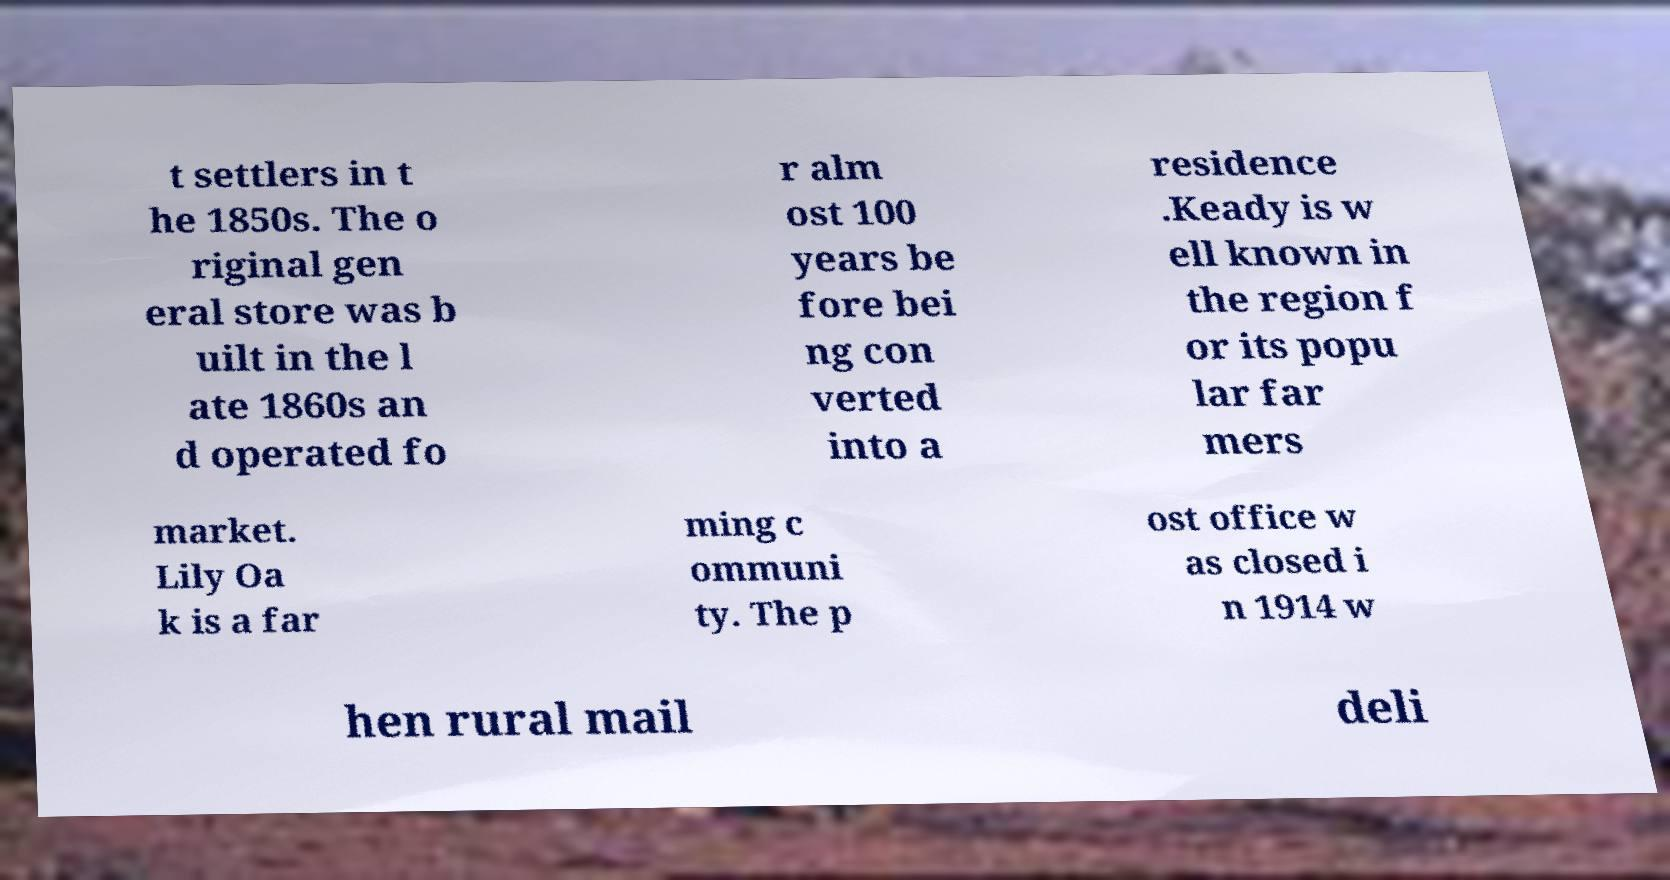Can you accurately transcribe the text from the provided image for me? t settlers in t he 1850s. The o riginal gen eral store was b uilt in the l ate 1860s an d operated fo r alm ost 100 years be fore bei ng con verted into a residence .Keady is w ell known in the region f or its popu lar far mers market. Lily Oa k is a far ming c ommuni ty. The p ost office w as closed i n 1914 w hen rural mail deli 